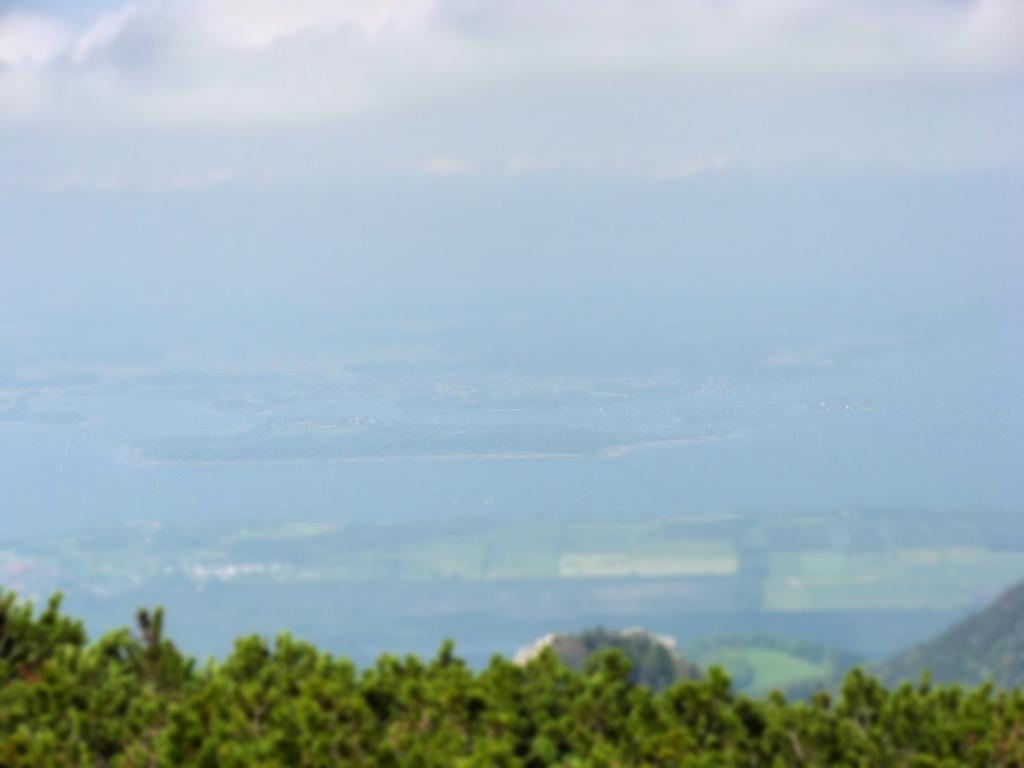What is located at the bottom of the image? There are plants at the bottom of the image. How is the image taken? The image provides an aerial view. What can be observed about the background of the image? The background of the image is blurred. How many birds are flying in a triangle shape in the image? There are no birds present in the image, and therefore no shape or movement can be observed. 